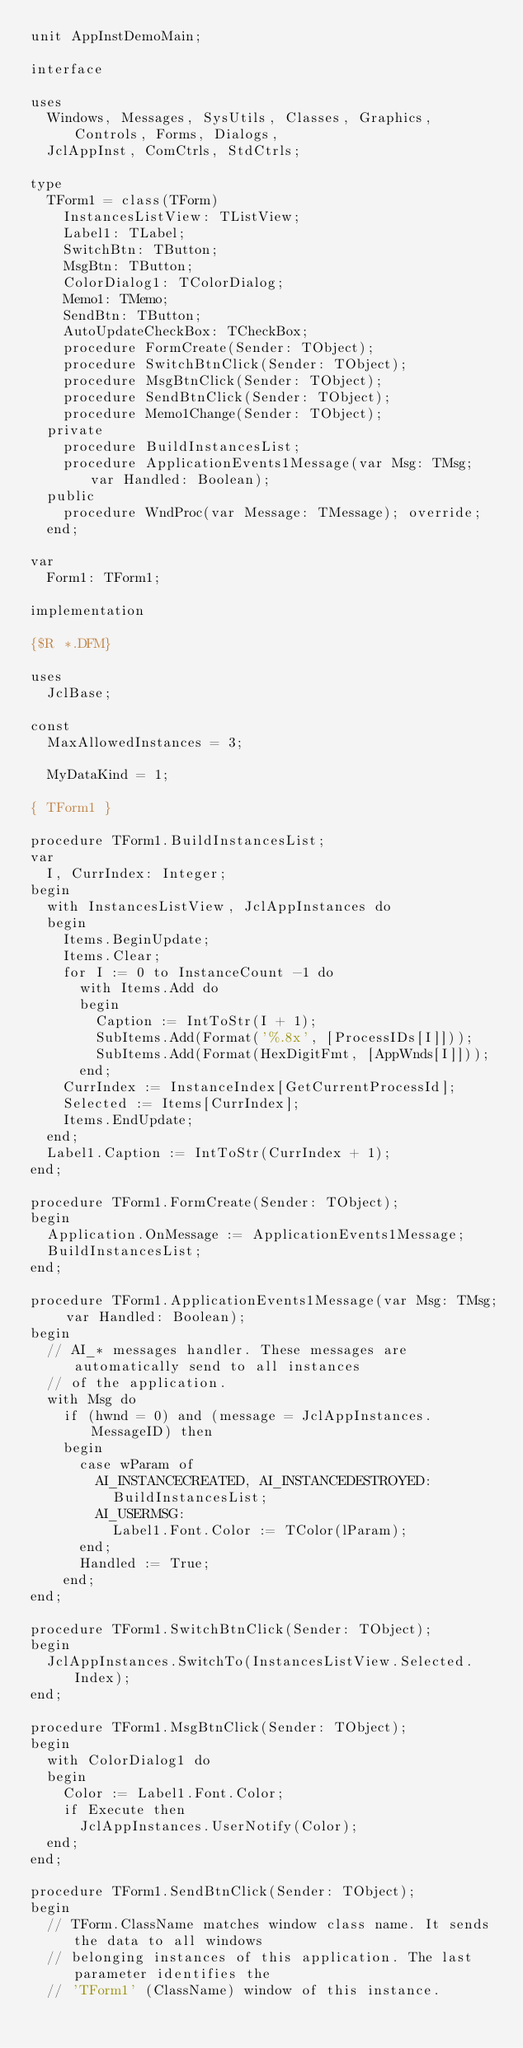Convert code to text. <code><loc_0><loc_0><loc_500><loc_500><_Pascal_>unit AppInstDemoMain;

interface

uses
  Windows, Messages, SysUtils, Classes, Graphics, Controls, Forms, Dialogs,
  JclAppInst, ComCtrls, StdCtrls;

type
  TForm1 = class(TForm)
    InstancesListView: TListView;
    Label1: TLabel;
    SwitchBtn: TButton;
    MsgBtn: TButton;
    ColorDialog1: TColorDialog;
    Memo1: TMemo;
    SendBtn: TButton;
    AutoUpdateCheckBox: TCheckBox;
    procedure FormCreate(Sender: TObject);
    procedure SwitchBtnClick(Sender: TObject);
    procedure MsgBtnClick(Sender: TObject);
    procedure SendBtnClick(Sender: TObject);
    procedure Memo1Change(Sender: TObject);
  private
    procedure BuildInstancesList;
    procedure ApplicationEvents1Message(var Msg: TMsg; var Handled: Boolean);
  public
    procedure WndProc(var Message: TMessage); override;
  end;

var
  Form1: TForm1;

implementation

{$R *.DFM}

uses
  JclBase;

const
  MaxAllowedInstances = 3;

  MyDataKind = 1;

{ TForm1 }

procedure TForm1.BuildInstancesList;
var
  I, CurrIndex: Integer;
begin
  with InstancesListView, JclAppInstances do
  begin
    Items.BeginUpdate;
    Items.Clear;
    for I := 0 to InstanceCount -1 do
      with Items.Add do
      begin
        Caption := IntToStr(I + 1);
        SubItems.Add(Format('%.8x', [ProcessIDs[I]]));
        SubItems.Add(Format(HexDigitFmt, [AppWnds[I]]));
      end;
    CurrIndex := InstanceIndex[GetCurrentProcessId];
    Selected := Items[CurrIndex];
    Items.EndUpdate;
  end;
  Label1.Caption := IntToStr(CurrIndex + 1);
end;

procedure TForm1.FormCreate(Sender: TObject);
begin
  Application.OnMessage := ApplicationEvents1Message;
  BuildInstancesList;
end;

procedure TForm1.ApplicationEvents1Message(var Msg: TMsg; var Handled: Boolean);
begin
  // AI_* messages handler. These messages are automatically send to all instances
  // of the application.
  with Msg do
    if (hwnd = 0) and (message = JclAppInstances.MessageID) then
    begin
      case wParam of
        AI_INSTANCECREATED, AI_INSTANCEDESTROYED:
          BuildInstancesList;
        AI_USERMSG:
          Label1.Font.Color := TColor(lParam);
      end;
      Handled := True;
    end;
end;

procedure TForm1.SwitchBtnClick(Sender: TObject);
begin
  JclAppInstances.SwitchTo(InstancesListView.Selected.Index);
end;

procedure TForm1.MsgBtnClick(Sender: TObject);
begin
  with ColorDialog1 do
  begin
    Color := Label1.Font.Color;
    if Execute then
      JclAppInstances.UserNotify(Color);
  end;
end;

procedure TForm1.SendBtnClick(Sender: TObject);
begin
  // TForm.ClassName matches window class name. It sends the data to all windows
  // belonging instances of this application. The last parameter identifies the
  // 'TForm1' (ClassName) window of this instance.</code> 